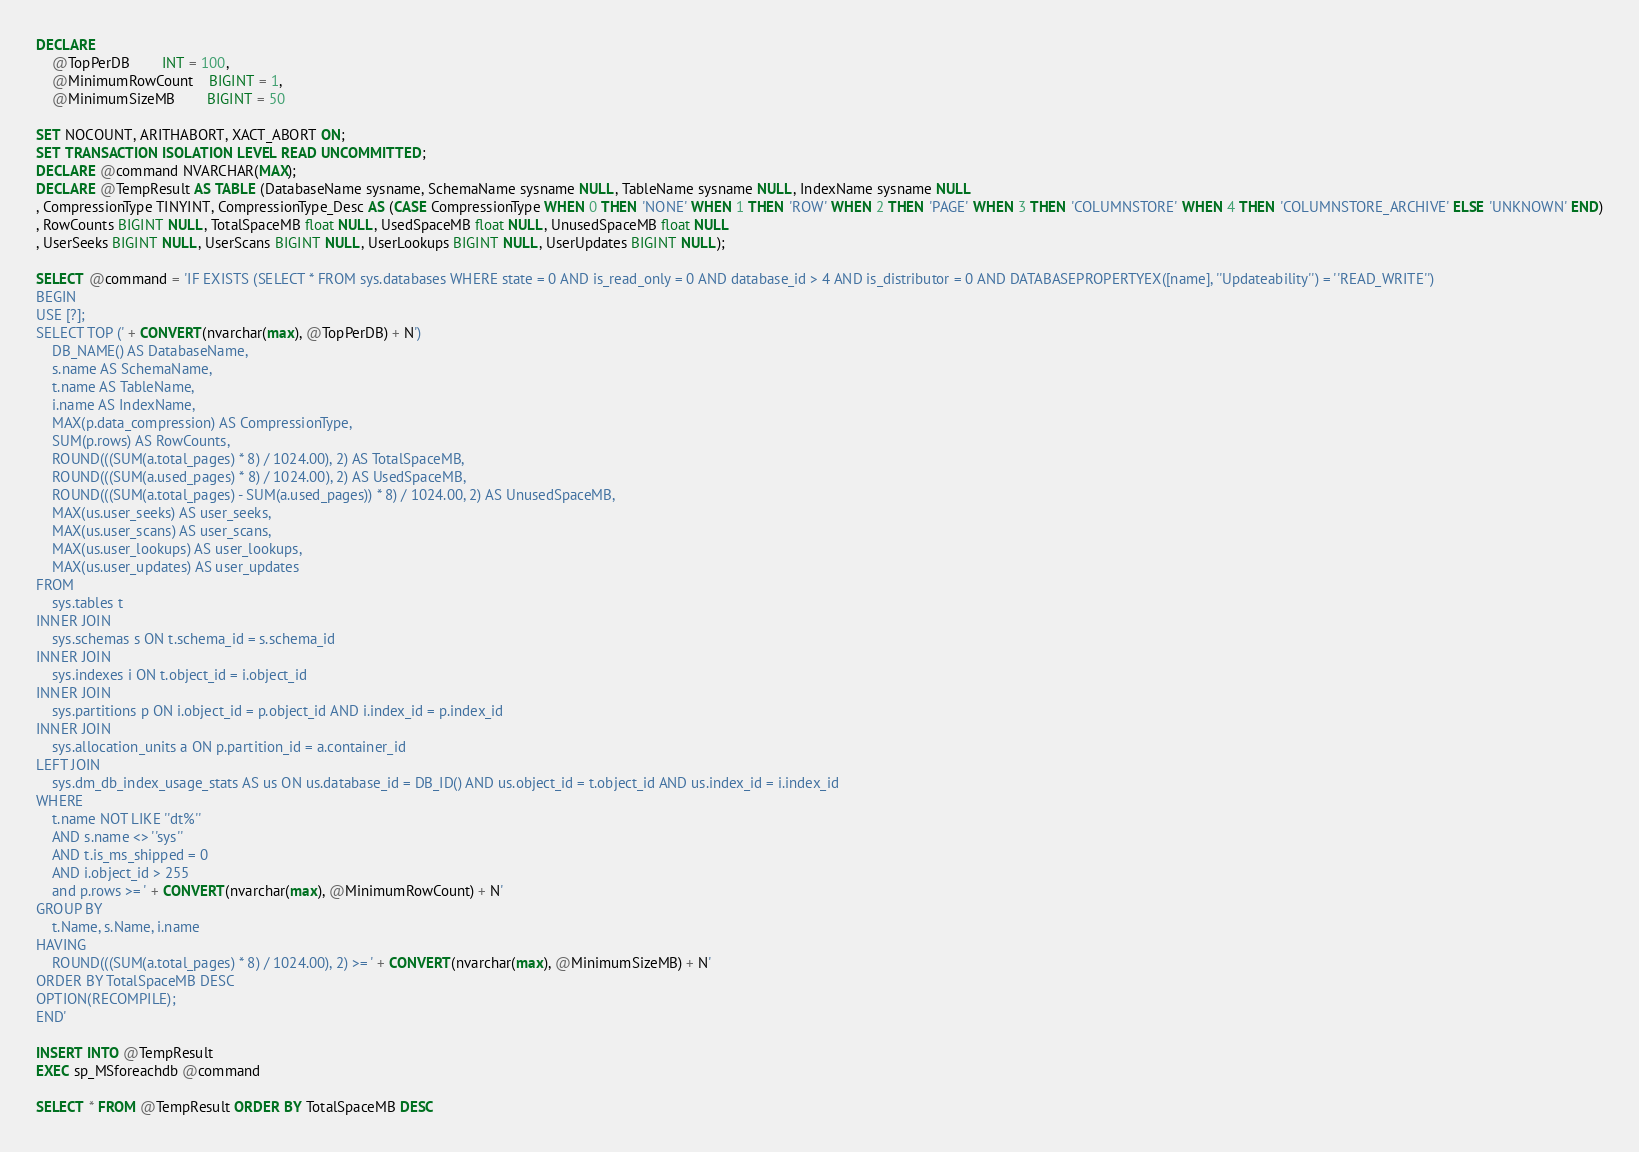<code> <loc_0><loc_0><loc_500><loc_500><_SQL_>DECLARE
	@TopPerDB		INT = 100,
	@MinimumRowCount	BIGINT = 1,
	@MinimumSizeMB		BIGINT = 50

SET NOCOUNT, ARITHABORT, XACT_ABORT ON;
SET TRANSACTION ISOLATION LEVEL READ UNCOMMITTED;
DECLARE @command NVARCHAR(MAX);
DECLARE @TempResult AS TABLE (DatabaseName sysname, SchemaName sysname NULL, TableName sysname NULL, IndexName sysname NULL
, CompressionType TINYINT, CompressionType_Desc AS (CASE CompressionType WHEN 0 THEN 'NONE' WHEN 1 THEN 'ROW' WHEN 2 THEN 'PAGE' WHEN 3 THEN 'COLUMNSTORE' WHEN 4 THEN 'COLUMNSTORE_ARCHIVE' ELSE 'UNKNOWN' END)
, RowCounts BIGINT NULL, TotalSpaceMB float NULL, UsedSpaceMB float NULL, UnusedSpaceMB float NULL
, UserSeeks BIGINT NULL, UserScans BIGINT NULL, UserLookups BIGINT NULL, UserUpdates BIGINT NULL);

SELECT @command = 'IF EXISTS (SELECT * FROM sys.databases WHERE state = 0 AND is_read_only = 0 AND database_id > 4 AND is_distributor = 0 AND DATABASEPROPERTYEX([name], ''Updateability'') = ''READ_WRITE'')
BEGIN
USE [?];
SELECT TOP (' + CONVERT(nvarchar(max), @TopPerDB) + N')
	DB_NAME() AS DatabaseName,
	s.name AS SchemaName,
	t.name AS TableName,
	i.name AS IndexName,
	MAX(p.data_compression) AS CompressionType,
	SUM(p.rows) AS RowCounts,
	ROUND(((SUM(a.total_pages) * 8) / 1024.00), 2) AS TotalSpaceMB,
	ROUND(((SUM(a.used_pages) * 8) / 1024.00), 2) AS UsedSpaceMB, 
	ROUND(((SUM(a.total_pages) - SUM(a.used_pages)) * 8) / 1024.00, 2) AS UnusedSpaceMB,
	MAX(us.user_seeks) AS user_seeks,
	MAX(us.user_scans) AS user_scans,
	MAX(us.user_lookups) AS user_lookups,
	MAX(us.user_updates) AS user_updates
FROM 
	sys.tables t
INNER JOIN 
	sys.schemas s ON t.schema_id = s.schema_id
INNER JOIN      
	sys.indexes i ON t.object_id = i.object_id
INNER JOIN 
	sys.partitions p ON i.object_id = p.object_id AND i.index_id = p.index_id
INNER JOIN 
	sys.allocation_units a ON p.partition_id = a.container_id
LEFT JOIN
	sys.dm_db_index_usage_stats AS us ON us.database_id = DB_ID() AND us.object_id = t.object_id AND us.index_id = i.index_id
WHERE 
	t.name NOT LIKE ''dt%''
	AND s.name <> ''sys''
	AND t.is_ms_shipped = 0
	AND i.object_id > 255 
	and p.rows >= ' + CONVERT(nvarchar(max), @MinimumRowCount) + N'
GROUP BY 
	t.Name, s.Name, i.name
HAVING
	ROUND(((SUM(a.total_pages) * 8) / 1024.00), 2) >= ' + CONVERT(nvarchar(max), @MinimumSizeMB) + N'
ORDER BY TotalSpaceMB DESC
OPTION(RECOMPILE);
END'

INSERT INTO @TempResult
EXEC sp_MSforeachdb @command

SELECT * FROM @TempResult ORDER BY TotalSpaceMB DESC
</code> 